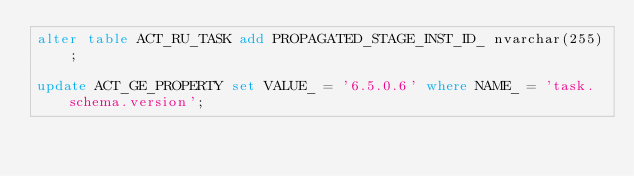<code> <loc_0><loc_0><loc_500><loc_500><_SQL_>alter table ACT_RU_TASK add PROPAGATED_STAGE_INST_ID_ nvarchar(255);

update ACT_GE_PROPERTY set VALUE_ = '6.5.0.6' where NAME_ = 'task.schema.version';
</code> 